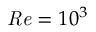Convert formula to latex. <formula><loc_0><loc_0><loc_500><loc_500>R e = 1 0 ^ { 3 }</formula> 